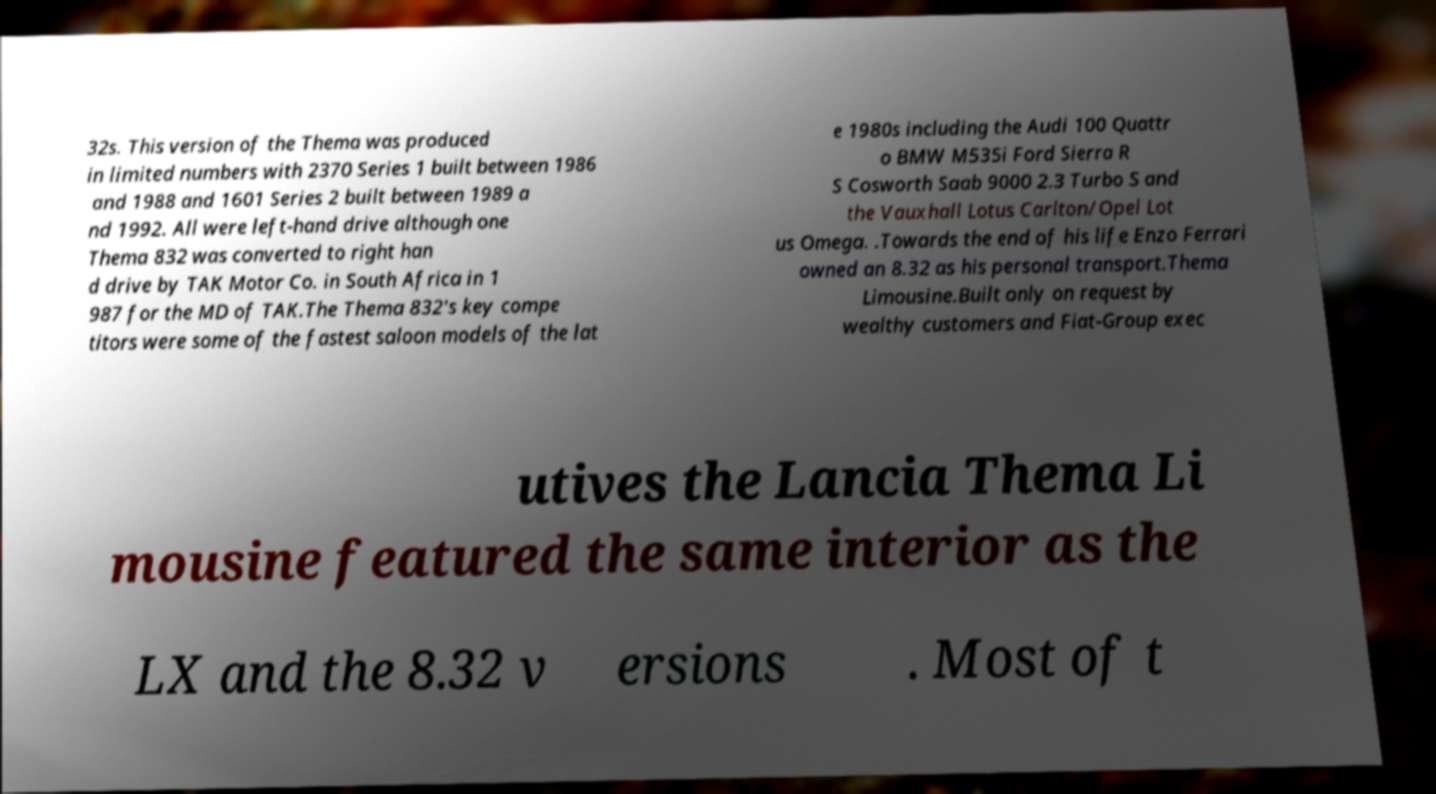Please identify and transcribe the text found in this image. 32s. This version of the Thema was produced in limited numbers with 2370 Series 1 built between 1986 and 1988 and 1601 Series 2 built between 1989 a nd 1992. All were left-hand drive although one Thema 832 was converted to right han d drive by TAK Motor Co. in South Africa in 1 987 for the MD of TAK.The Thema 832's key compe titors were some of the fastest saloon models of the lat e 1980s including the Audi 100 Quattr o BMW M535i Ford Sierra R S Cosworth Saab 9000 2.3 Turbo S and the Vauxhall Lotus Carlton/Opel Lot us Omega. .Towards the end of his life Enzo Ferrari owned an 8.32 as his personal transport.Thema Limousine.Built only on request by wealthy customers and Fiat-Group exec utives the Lancia Thema Li mousine featured the same interior as the LX and the 8.32 v ersions . Most of t 